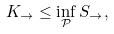Convert formula to latex. <formula><loc_0><loc_0><loc_500><loc_500>K _ { \rightarrow } \leq \inf _ { \mathcal { P } } S _ { \rightarrow } ,</formula> 